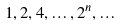Convert formula to latex. <formula><loc_0><loc_0><loc_500><loc_500>1 , 2 , 4 , \dots , 2 ^ { n } , \dots</formula> 